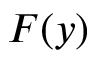Convert formula to latex. <formula><loc_0><loc_0><loc_500><loc_500>F ( y )</formula> 